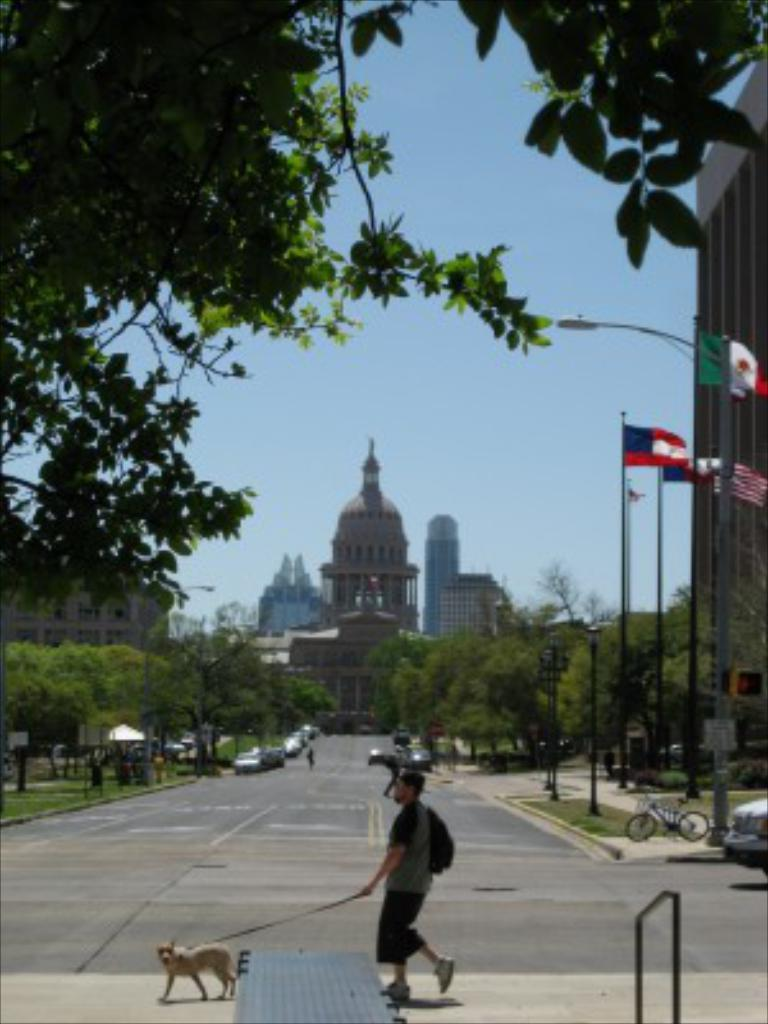What is the person in the image doing? The person is walking on the road. What is the person holding while walking? The person is holding a dog leash. What type of structures can be seen in the image? There are buildings in the image. What type of vegetation is present in the image? There are trees in the image. What type of transportation can be seen in the image? There are vehicles in the image. What type of decorative or symbolic objects are present in the image? There are flags in the image. What type of illumination is present in the image? There are lights in the image. What can be seen in the background of the image? The sky is visible in the background of the image. How does the person connect to the internet while walking in the image? There is no information about the person connecting to the internet in the image. What type of wind instrument is the person playing while walking in the image? There is no wind instrument present in the image; the person is holding a dog leash. 